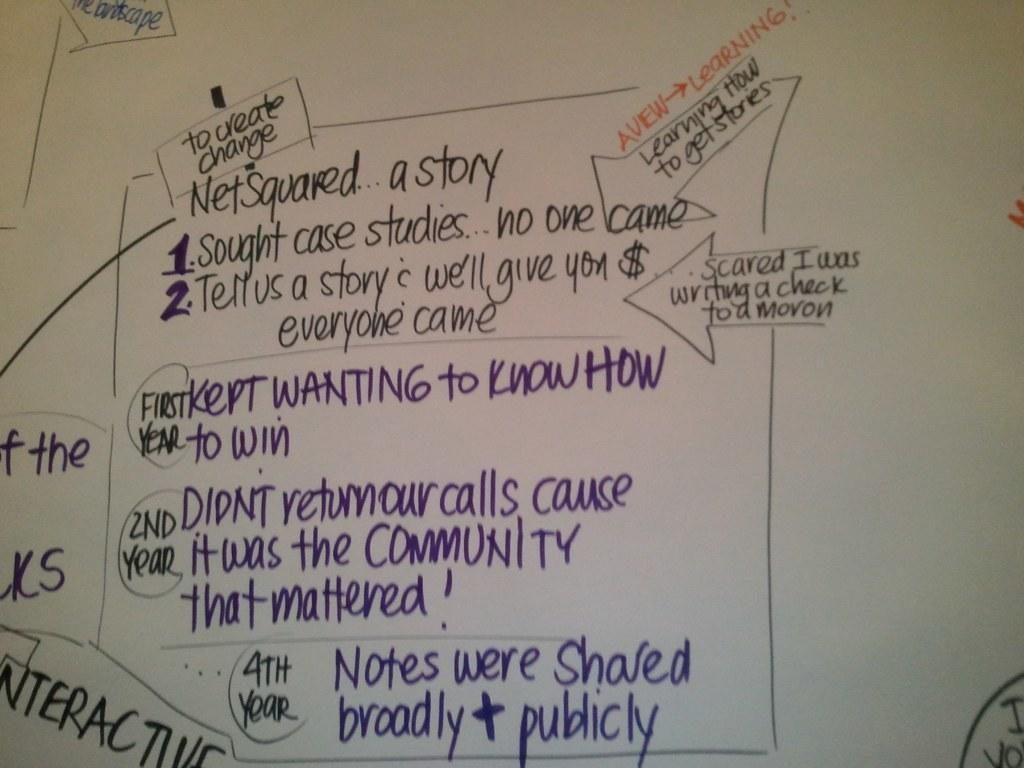<image>
Write a terse but informative summary of the picture. A white board with a chart relating to getting money for a community, including the fact that notes were shared broadly and publicly. 